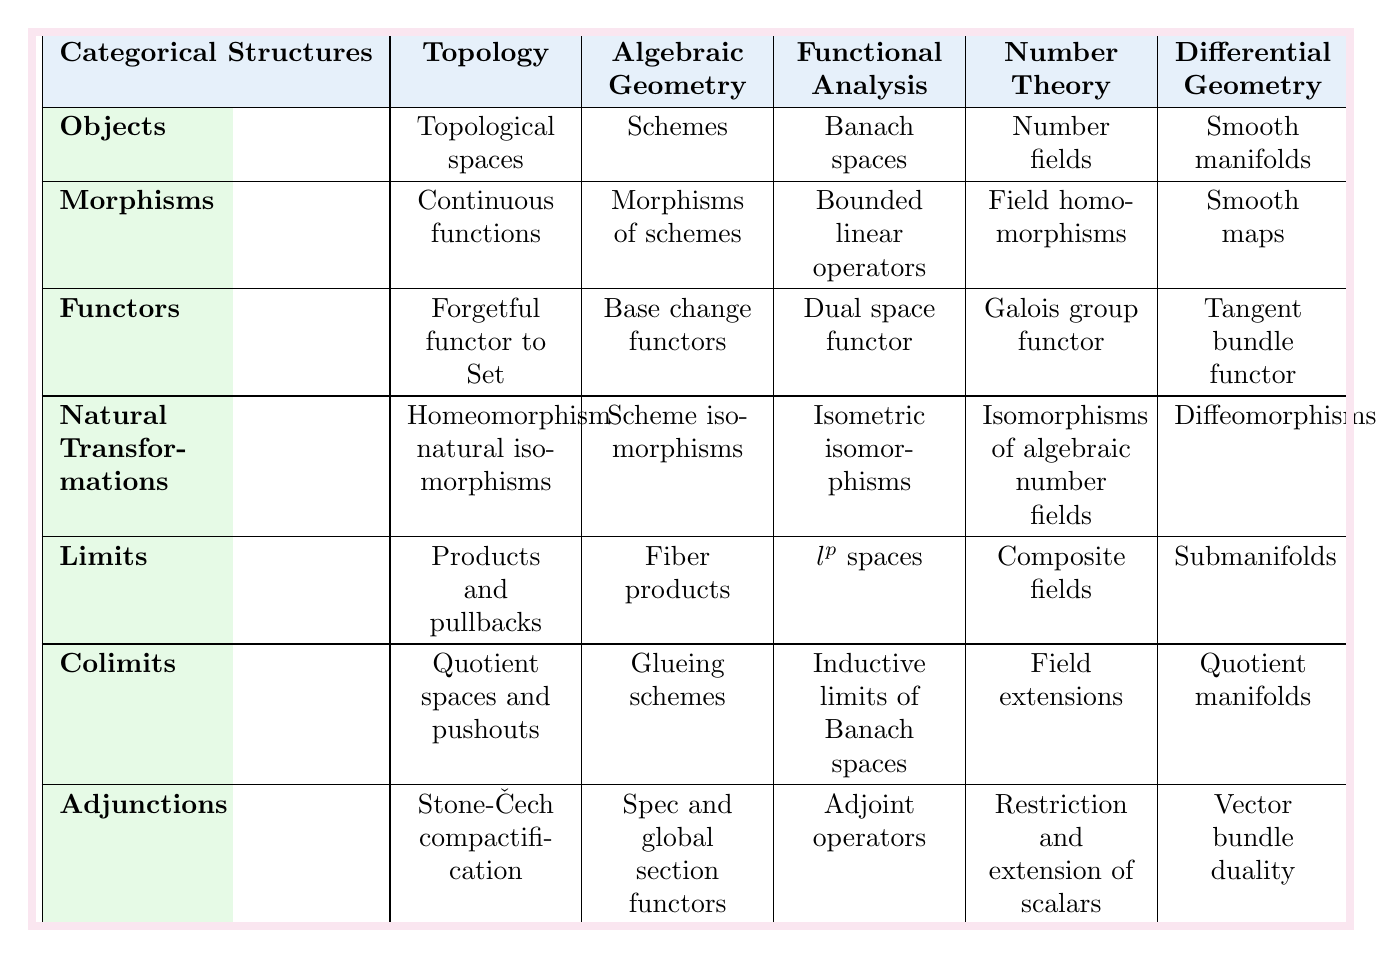What are the objects classified under Algebraic Geometry? According to the table, the objects in Algebraic Geometry are "Schemes." This can be found in the row for "Objects" under the Algebraic Geometry column.
Answer: Schemes Which mathematical field has "Bounded linear operators" as its morphisms? Looking at the table, "Bounded linear operators" are listed under the Morphisms column for Functional Analysis, indicating this is the corresponding field.
Answer: Functional Analysis Do all fields have a different structure for natural transformations? Upon checking the table, each field has a unique description for natural transformations: "Homeomorphism natural isomorphisms" for Topology, "Scheme isomorphisms" for Algebraic Geometry, "Isometric isomorphisms" for Functional Analysis, "Isomorphisms of algebraic number fields" for Number Theory, and "Diffeomorphisms" for Differential Geometry. Thus, they do all differ.
Answer: Yes In which field do you find "Fiber products" categorized under limits? The table shows that "Fiber products" is listed under the Limits section for Algebraic Geometry. Therefore, this is the field associated with that limit structure.
Answer: Algebraic Geometry Which field has the same object and morphism structure as Topology? When analyzing the table, "Topology" has the object as "Topological spaces" and morphism as "Continuous functions." It does not match any other field; therefore, none share this structure.
Answer: None What is the relationship between objects and morphisms in Functional Analysis? In Functional Analysis, the object is "Banach spaces" and the morphisms are "Bounded linear operators." This indicates that bounded linear operators are the functions defined between Banach spaces, showcasing their relationship as morphisms connecting the objects.
Answer: Bounded linear operators map Banach spaces What do we observe about the limits in Number Theory compared to those in Differential Geometry? The limits in Number Theory are "Composite fields," whereas in Differential Geometry, they are "Submanifolds." Comparing both shows that they have different structures as reflected in the table.
Answer: Different structures Identify the functor described for Topology. The table indicates that the functor in Topology is the "Forgetful functor to Set." This can be directly referenced in the Functors row for Topology.
Answer: Forgetful functor to Set In how many fields is "Adjunctions" existing, and what are they? From the table, "Adjunctions" exists in five fields, with their descriptions as follows: "Stone-Čech compactification" in Topology, "Spec and global section functors" in Algebraic Geometry, "Adjoint operators" in Functional Analysis, "Restriction and extension of scalars" in Number Theory, and "Vector bundle duality" in Differential Geometry. This indicates a common categorical structure across these mathematical areas.
Answer: 5 fields If you take the limits associated with Topology and Functional Analysis, how do they differ? The limits for Topology are "Products and pullbacks," while for Functional Analysis, they are "$l^p$ spaces." There’s no similarity as both structures serve different purposes in their respective fields.
Answer: They differ 